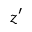<formula> <loc_0><loc_0><loc_500><loc_500>z ^ { \prime }</formula> 